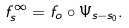Convert formula to latex. <formula><loc_0><loc_0><loc_500><loc_500>f ^ { \infty } _ { s } = f _ { o } \circ \Psi _ { s - s _ { 0 } } .</formula> 